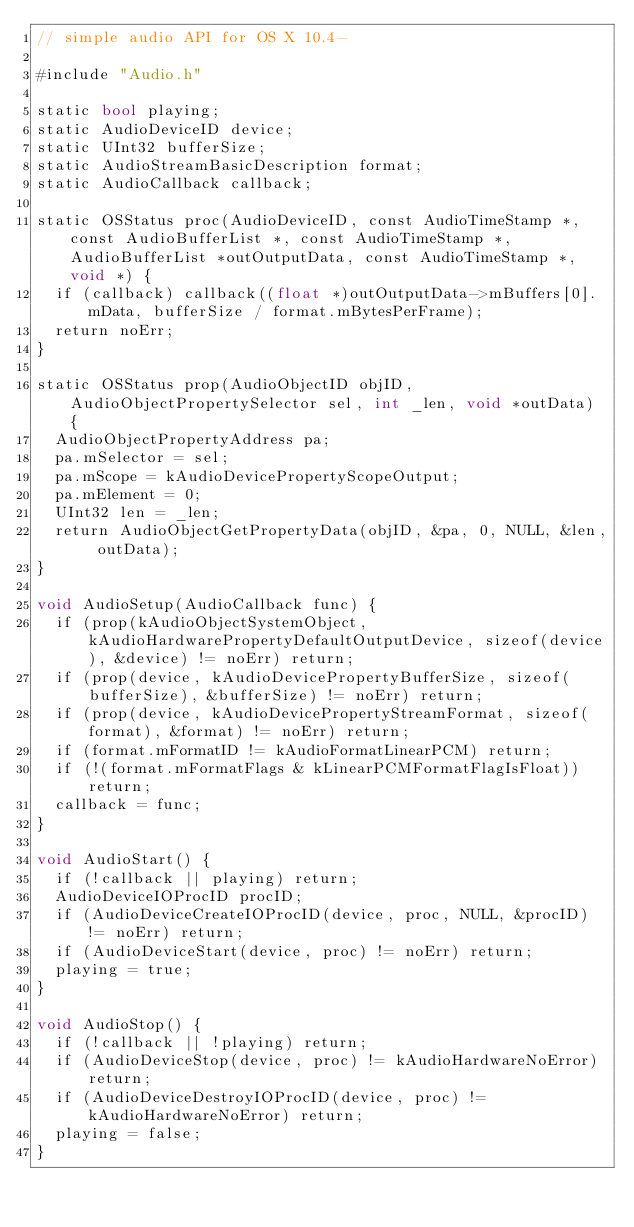<code> <loc_0><loc_0><loc_500><loc_500><_ObjectiveC_>// simple audio API for OS X 10.4-

#include "Audio.h"

static bool playing;
static AudioDeviceID device;
static UInt32 bufferSize;
static AudioStreamBasicDescription format;
static AudioCallback callback;

static OSStatus proc(AudioDeviceID, const AudioTimeStamp *, const AudioBufferList *, const AudioTimeStamp *, AudioBufferList *outOutputData, const AudioTimeStamp *, void *) {
	if (callback) callback((float *)outOutputData->mBuffers[0].mData, bufferSize / format.mBytesPerFrame);
	return noErr;
}

static OSStatus prop(AudioObjectID objID, AudioObjectPropertySelector sel, int _len, void *outData) {
	AudioObjectPropertyAddress pa;
	pa.mSelector = sel;
	pa.mScope = kAudioDevicePropertyScopeOutput;
	pa.mElement = 0;
	UInt32 len = _len;
	return AudioObjectGetPropertyData(objID, &pa, 0, NULL, &len, outData);
}

void AudioSetup(AudioCallback func) {
	if (prop(kAudioObjectSystemObject, kAudioHardwarePropertyDefaultOutputDevice, sizeof(device), &device) != noErr) return;
	if (prop(device, kAudioDevicePropertyBufferSize, sizeof(bufferSize), &bufferSize) != noErr) return;
	if (prop(device, kAudioDevicePropertyStreamFormat, sizeof(format), &format) != noErr) return;
	if (format.mFormatID != kAudioFormatLinearPCM) return;
	if (!(format.mFormatFlags & kLinearPCMFormatFlagIsFloat)) return;
	callback = func;
}

void AudioStart() {
	if (!callback || playing) return;
	AudioDeviceIOProcID procID;
	if (AudioDeviceCreateIOProcID(device, proc, NULL, &procID) != noErr) return;
	if (AudioDeviceStart(device, proc) != noErr) return;
	playing = true;
}

void AudioStop() {
	if (!callback || !playing) return;
	if (AudioDeviceStop(device, proc) != kAudioHardwareNoError) return;
	if (AudioDeviceDestroyIOProcID(device, proc) != kAudioHardwareNoError) return;
	playing = false;
}

</code> 